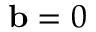<formula> <loc_0><loc_0><loc_500><loc_500>b = 0</formula> 